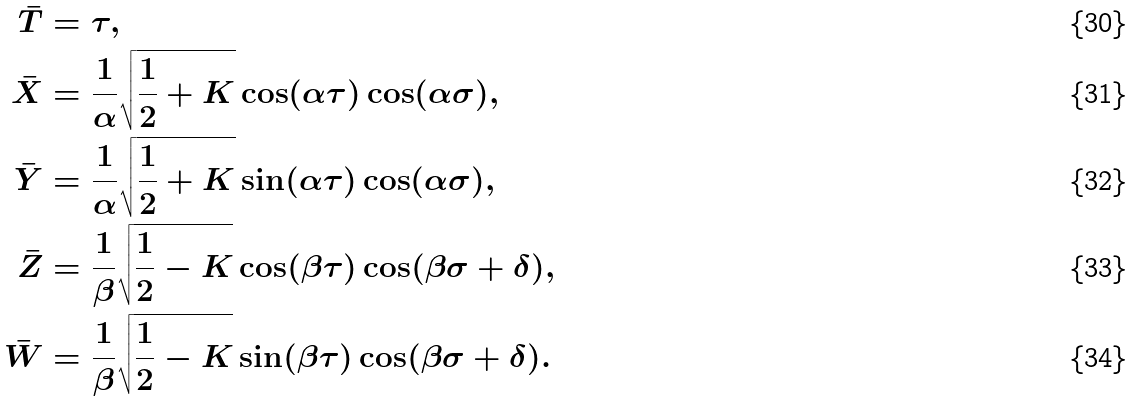<formula> <loc_0><loc_0><loc_500><loc_500>\bar { T } & = \tau , \\ \bar { X } & = \frac { 1 } { \alpha } \sqrt { \frac { 1 } { 2 } + K } \cos ( \alpha \tau ) \cos ( \alpha \sigma ) , \\ \bar { Y } & = \frac { 1 } { \alpha } \sqrt { \frac { 1 } { 2 } + K } \sin ( \alpha \tau ) \cos ( \alpha \sigma ) , \\ \bar { Z } & = \frac { 1 } { \beta } \sqrt { \frac { 1 } { 2 } - K } \cos ( \beta \tau ) \cos ( \beta \sigma + \delta ) , \\ \bar { W } & = \frac { 1 } { \beta } \sqrt { \frac { 1 } { 2 } - K } \sin ( \beta \tau ) \cos ( \beta \sigma + \delta ) .</formula> 